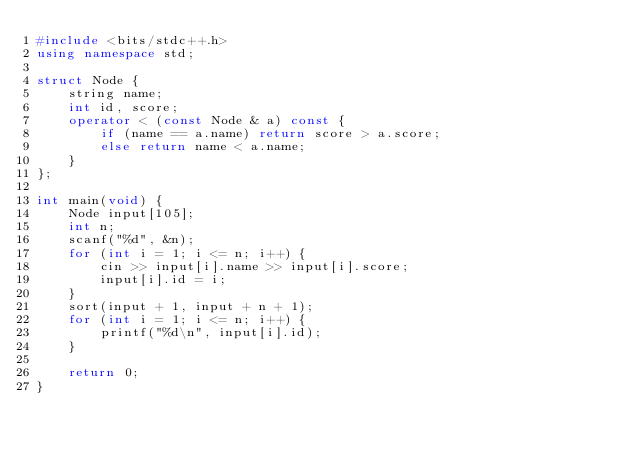Convert code to text. <code><loc_0><loc_0><loc_500><loc_500><_C++_>#include <bits/stdc++.h>
using namespace std;

struct Node {
    string name;
    int id, score;
    operator < (const Node & a) const {
        if (name == a.name) return score > a.score;
        else return name < a.name;
    }
};

int main(void) {
    Node input[105];
    int n;
    scanf("%d", &n);
    for (int i = 1; i <= n; i++) {
        cin >> input[i].name >> input[i].score;
        input[i].id = i;
    }
    sort(input + 1, input + n + 1);
    for (int i = 1; i <= n; i++) {
        printf("%d\n", input[i].id);
    }

    return 0;
}</code> 